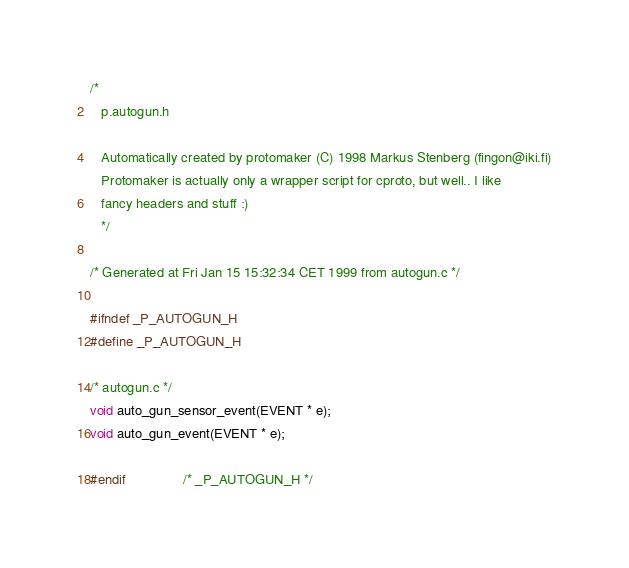<code> <loc_0><loc_0><loc_500><loc_500><_C_>
/*
   p.autogun.h

   Automatically created by protomaker (C) 1998 Markus Stenberg (fingon@iki.fi)
   Protomaker is actually only a wrapper script for cproto, but well.. I like
   fancy headers and stuff :)
   */

/* Generated at Fri Jan 15 15:32:34 CET 1999 from autogun.c */

#ifndef _P_AUTOGUN_H
#define _P_AUTOGUN_H

/* autogun.c */
void auto_gun_sensor_event(EVENT * e);
void auto_gun_event(EVENT * e);

#endif				/* _P_AUTOGUN_H */
</code> 